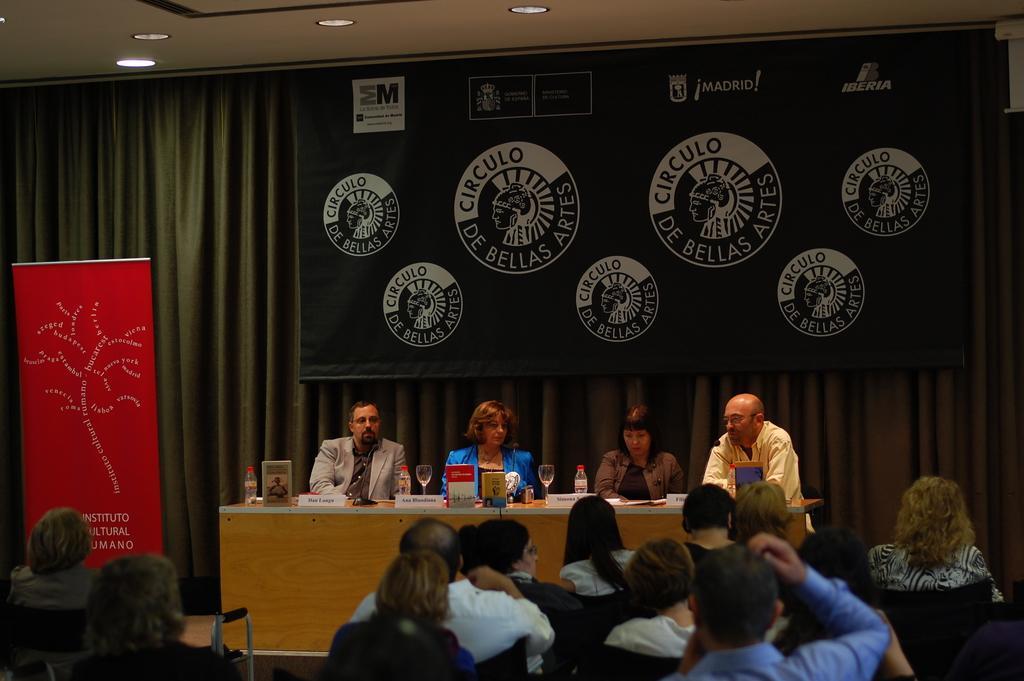In one or two sentences, can you explain what this image depicts? In this image it looks like a conference. In the middle there is a table on which there are glasses,boards and bottles. Behind them there are four people who are sitting in the chairs. In front of them there are spectators who are sitting in the chairs. In the background there is a curtain. At the top there is ceiling with the lights. On the left side there is a banner. At the top there is a hoarding. 